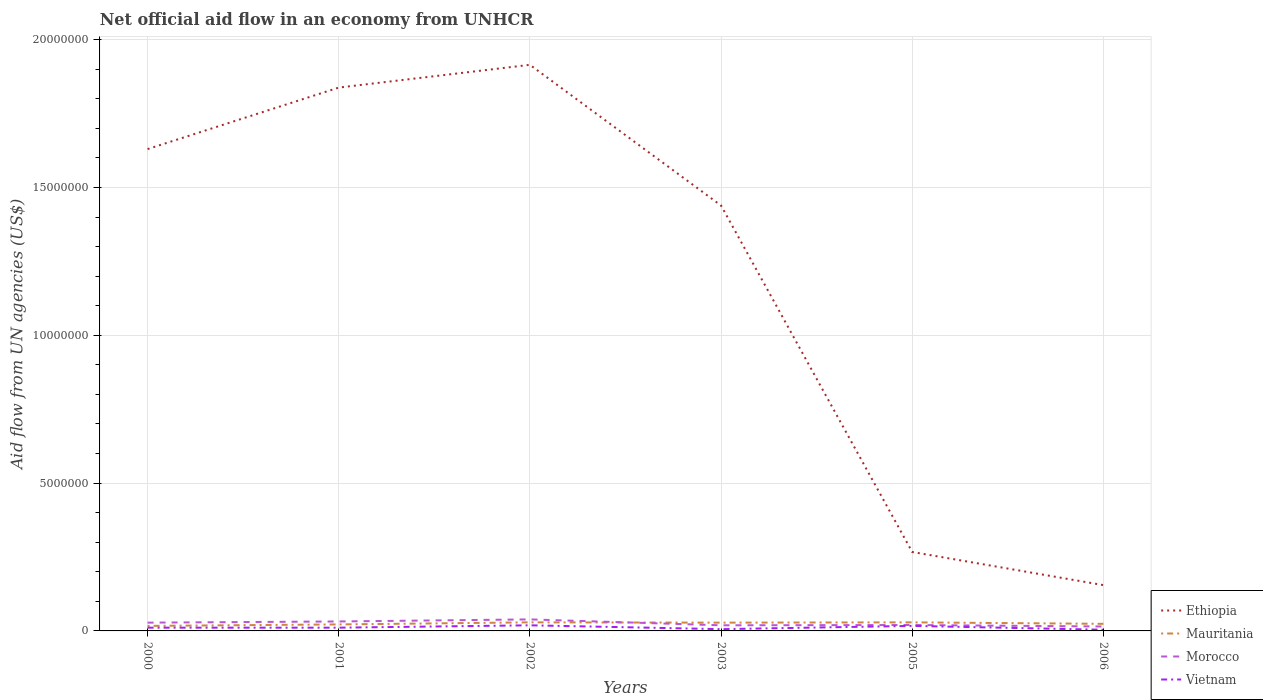How many different coloured lines are there?
Provide a succinct answer. 4. Does the line corresponding to Ethiopia intersect with the line corresponding to Vietnam?
Your answer should be very brief. No. What is the difference between the highest and the second highest net official aid flow in Vietnam?
Your answer should be compact. 1.50e+05. Is the net official aid flow in Mauritania strictly greater than the net official aid flow in Vietnam over the years?
Keep it short and to the point. No. How many lines are there?
Provide a short and direct response. 4. How many years are there in the graph?
Your response must be concise. 6. What is the difference between two consecutive major ticks on the Y-axis?
Offer a terse response. 5.00e+06. Does the graph contain any zero values?
Your answer should be compact. No. Does the graph contain grids?
Ensure brevity in your answer.  Yes. What is the title of the graph?
Provide a succinct answer. Net official aid flow in an economy from UNHCR. What is the label or title of the Y-axis?
Make the answer very short. Aid flow from UN agencies (US$). What is the Aid flow from UN agencies (US$) of Ethiopia in 2000?
Offer a very short reply. 1.63e+07. What is the Aid flow from UN agencies (US$) of Vietnam in 2000?
Offer a terse response. 1.10e+05. What is the Aid flow from UN agencies (US$) of Ethiopia in 2001?
Offer a terse response. 1.84e+07. What is the Aid flow from UN agencies (US$) in Vietnam in 2001?
Offer a very short reply. 1.10e+05. What is the Aid flow from UN agencies (US$) of Ethiopia in 2002?
Ensure brevity in your answer.  1.92e+07. What is the Aid flow from UN agencies (US$) in Mauritania in 2002?
Give a very brief answer. 2.90e+05. What is the Aid flow from UN agencies (US$) in Vietnam in 2002?
Your answer should be compact. 1.90e+05. What is the Aid flow from UN agencies (US$) in Ethiopia in 2003?
Give a very brief answer. 1.44e+07. What is the Aid flow from UN agencies (US$) of Ethiopia in 2005?
Keep it short and to the point. 2.67e+06. What is the Aid flow from UN agencies (US$) of Mauritania in 2005?
Offer a very short reply. 2.90e+05. What is the Aid flow from UN agencies (US$) in Morocco in 2005?
Give a very brief answer. 2.00e+05. What is the Aid flow from UN agencies (US$) in Ethiopia in 2006?
Your response must be concise. 1.55e+06. What is the Aid flow from UN agencies (US$) of Mauritania in 2006?
Your answer should be compact. 2.40e+05. What is the Aid flow from UN agencies (US$) in Morocco in 2006?
Ensure brevity in your answer.  1.50e+05. What is the Aid flow from UN agencies (US$) in Vietnam in 2006?
Your response must be concise. 4.00e+04. Across all years, what is the maximum Aid flow from UN agencies (US$) of Ethiopia?
Your response must be concise. 1.92e+07. Across all years, what is the maximum Aid flow from UN agencies (US$) of Morocco?
Offer a terse response. 3.90e+05. Across all years, what is the maximum Aid flow from UN agencies (US$) in Vietnam?
Keep it short and to the point. 1.90e+05. Across all years, what is the minimum Aid flow from UN agencies (US$) of Ethiopia?
Offer a very short reply. 1.55e+06. What is the total Aid flow from UN agencies (US$) of Ethiopia in the graph?
Your answer should be compact. 7.24e+07. What is the total Aid flow from UN agencies (US$) in Mauritania in the graph?
Your response must be concise. 1.49e+06. What is the total Aid flow from UN agencies (US$) in Morocco in the graph?
Offer a very short reply. 1.53e+06. What is the total Aid flow from UN agencies (US$) in Vietnam in the graph?
Offer a terse response. 6.80e+05. What is the difference between the Aid flow from UN agencies (US$) of Ethiopia in 2000 and that in 2001?
Your response must be concise. -2.08e+06. What is the difference between the Aid flow from UN agencies (US$) of Vietnam in 2000 and that in 2001?
Your answer should be very brief. 0. What is the difference between the Aid flow from UN agencies (US$) of Ethiopia in 2000 and that in 2002?
Your response must be concise. -2.85e+06. What is the difference between the Aid flow from UN agencies (US$) of Vietnam in 2000 and that in 2002?
Your response must be concise. -8.00e+04. What is the difference between the Aid flow from UN agencies (US$) in Ethiopia in 2000 and that in 2003?
Ensure brevity in your answer.  1.91e+06. What is the difference between the Aid flow from UN agencies (US$) in Ethiopia in 2000 and that in 2005?
Make the answer very short. 1.36e+07. What is the difference between the Aid flow from UN agencies (US$) in Morocco in 2000 and that in 2005?
Ensure brevity in your answer.  8.00e+04. What is the difference between the Aid flow from UN agencies (US$) in Ethiopia in 2000 and that in 2006?
Keep it short and to the point. 1.48e+07. What is the difference between the Aid flow from UN agencies (US$) in Mauritania in 2000 and that in 2006?
Make the answer very short. -7.00e+04. What is the difference between the Aid flow from UN agencies (US$) of Ethiopia in 2001 and that in 2002?
Keep it short and to the point. -7.70e+05. What is the difference between the Aid flow from UN agencies (US$) in Morocco in 2001 and that in 2002?
Provide a succinct answer. -7.00e+04. What is the difference between the Aid flow from UN agencies (US$) of Ethiopia in 2001 and that in 2003?
Make the answer very short. 3.99e+06. What is the difference between the Aid flow from UN agencies (US$) of Morocco in 2001 and that in 2003?
Ensure brevity in your answer.  1.30e+05. What is the difference between the Aid flow from UN agencies (US$) of Ethiopia in 2001 and that in 2005?
Make the answer very short. 1.57e+07. What is the difference between the Aid flow from UN agencies (US$) in Mauritania in 2001 and that in 2005?
Offer a terse response. -7.00e+04. What is the difference between the Aid flow from UN agencies (US$) of Morocco in 2001 and that in 2005?
Keep it short and to the point. 1.20e+05. What is the difference between the Aid flow from UN agencies (US$) of Vietnam in 2001 and that in 2005?
Give a very brief answer. -6.00e+04. What is the difference between the Aid flow from UN agencies (US$) of Ethiopia in 2001 and that in 2006?
Offer a very short reply. 1.68e+07. What is the difference between the Aid flow from UN agencies (US$) of Ethiopia in 2002 and that in 2003?
Your response must be concise. 4.76e+06. What is the difference between the Aid flow from UN agencies (US$) of Morocco in 2002 and that in 2003?
Offer a terse response. 2.00e+05. What is the difference between the Aid flow from UN agencies (US$) of Ethiopia in 2002 and that in 2005?
Ensure brevity in your answer.  1.65e+07. What is the difference between the Aid flow from UN agencies (US$) in Mauritania in 2002 and that in 2005?
Provide a short and direct response. 0. What is the difference between the Aid flow from UN agencies (US$) in Morocco in 2002 and that in 2005?
Keep it short and to the point. 1.90e+05. What is the difference between the Aid flow from UN agencies (US$) of Vietnam in 2002 and that in 2005?
Provide a short and direct response. 2.00e+04. What is the difference between the Aid flow from UN agencies (US$) of Ethiopia in 2002 and that in 2006?
Provide a short and direct response. 1.76e+07. What is the difference between the Aid flow from UN agencies (US$) in Mauritania in 2002 and that in 2006?
Your response must be concise. 5.00e+04. What is the difference between the Aid flow from UN agencies (US$) of Vietnam in 2002 and that in 2006?
Offer a terse response. 1.50e+05. What is the difference between the Aid flow from UN agencies (US$) of Ethiopia in 2003 and that in 2005?
Your answer should be compact. 1.17e+07. What is the difference between the Aid flow from UN agencies (US$) of Vietnam in 2003 and that in 2005?
Your answer should be compact. -1.10e+05. What is the difference between the Aid flow from UN agencies (US$) of Ethiopia in 2003 and that in 2006?
Provide a succinct answer. 1.28e+07. What is the difference between the Aid flow from UN agencies (US$) of Morocco in 2003 and that in 2006?
Keep it short and to the point. 4.00e+04. What is the difference between the Aid flow from UN agencies (US$) in Vietnam in 2003 and that in 2006?
Keep it short and to the point. 2.00e+04. What is the difference between the Aid flow from UN agencies (US$) in Ethiopia in 2005 and that in 2006?
Your answer should be compact. 1.12e+06. What is the difference between the Aid flow from UN agencies (US$) of Morocco in 2005 and that in 2006?
Your answer should be very brief. 5.00e+04. What is the difference between the Aid flow from UN agencies (US$) in Ethiopia in 2000 and the Aid flow from UN agencies (US$) in Mauritania in 2001?
Offer a terse response. 1.61e+07. What is the difference between the Aid flow from UN agencies (US$) in Ethiopia in 2000 and the Aid flow from UN agencies (US$) in Morocco in 2001?
Provide a succinct answer. 1.60e+07. What is the difference between the Aid flow from UN agencies (US$) of Ethiopia in 2000 and the Aid flow from UN agencies (US$) of Vietnam in 2001?
Make the answer very short. 1.62e+07. What is the difference between the Aid flow from UN agencies (US$) in Mauritania in 2000 and the Aid flow from UN agencies (US$) in Morocco in 2001?
Your answer should be very brief. -1.50e+05. What is the difference between the Aid flow from UN agencies (US$) in Morocco in 2000 and the Aid flow from UN agencies (US$) in Vietnam in 2001?
Ensure brevity in your answer.  1.70e+05. What is the difference between the Aid flow from UN agencies (US$) of Ethiopia in 2000 and the Aid flow from UN agencies (US$) of Mauritania in 2002?
Provide a short and direct response. 1.60e+07. What is the difference between the Aid flow from UN agencies (US$) of Ethiopia in 2000 and the Aid flow from UN agencies (US$) of Morocco in 2002?
Offer a very short reply. 1.59e+07. What is the difference between the Aid flow from UN agencies (US$) of Ethiopia in 2000 and the Aid flow from UN agencies (US$) of Vietnam in 2002?
Your answer should be compact. 1.61e+07. What is the difference between the Aid flow from UN agencies (US$) in Mauritania in 2000 and the Aid flow from UN agencies (US$) in Vietnam in 2002?
Offer a very short reply. -2.00e+04. What is the difference between the Aid flow from UN agencies (US$) of Ethiopia in 2000 and the Aid flow from UN agencies (US$) of Mauritania in 2003?
Your response must be concise. 1.60e+07. What is the difference between the Aid flow from UN agencies (US$) of Ethiopia in 2000 and the Aid flow from UN agencies (US$) of Morocco in 2003?
Provide a short and direct response. 1.61e+07. What is the difference between the Aid flow from UN agencies (US$) in Ethiopia in 2000 and the Aid flow from UN agencies (US$) in Vietnam in 2003?
Provide a succinct answer. 1.62e+07. What is the difference between the Aid flow from UN agencies (US$) of Mauritania in 2000 and the Aid flow from UN agencies (US$) of Morocco in 2003?
Your answer should be compact. -2.00e+04. What is the difference between the Aid flow from UN agencies (US$) in Ethiopia in 2000 and the Aid flow from UN agencies (US$) in Mauritania in 2005?
Provide a short and direct response. 1.60e+07. What is the difference between the Aid flow from UN agencies (US$) of Ethiopia in 2000 and the Aid flow from UN agencies (US$) of Morocco in 2005?
Provide a succinct answer. 1.61e+07. What is the difference between the Aid flow from UN agencies (US$) in Ethiopia in 2000 and the Aid flow from UN agencies (US$) in Vietnam in 2005?
Your response must be concise. 1.61e+07. What is the difference between the Aid flow from UN agencies (US$) of Mauritania in 2000 and the Aid flow from UN agencies (US$) of Vietnam in 2005?
Your answer should be compact. 0. What is the difference between the Aid flow from UN agencies (US$) of Ethiopia in 2000 and the Aid flow from UN agencies (US$) of Mauritania in 2006?
Provide a succinct answer. 1.61e+07. What is the difference between the Aid flow from UN agencies (US$) of Ethiopia in 2000 and the Aid flow from UN agencies (US$) of Morocco in 2006?
Offer a terse response. 1.62e+07. What is the difference between the Aid flow from UN agencies (US$) of Ethiopia in 2000 and the Aid flow from UN agencies (US$) of Vietnam in 2006?
Your response must be concise. 1.63e+07. What is the difference between the Aid flow from UN agencies (US$) of Mauritania in 2000 and the Aid flow from UN agencies (US$) of Vietnam in 2006?
Ensure brevity in your answer.  1.30e+05. What is the difference between the Aid flow from UN agencies (US$) of Morocco in 2000 and the Aid flow from UN agencies (US$) of Vietnam in 2006?
Offer a terse response. 2.40e+05. What is the difference between the Aid flow from UN agencies (US$) in Ethiopia in 2001 and the Aid flow from UN agencies (US$) in Mauritania in 2002?
Give a very brief answer. 1.81e+07. What is the difference between the Aid flow from UN agencies (US$) of Ethiopia in 2001 and the Aid flow from UN agencies (US$) of Morocco in 2002?
Provide a succinct answer. 1.80e+07. What is the difference between the Aid flow from UN agencies (US$) of Ethiopia in 2001 and the Aid flow from UN agencies (US$) of Vietnam in 2002?
Ensure brevity in your answer.  1.82e+07. What is the difference between the Aid flow from UN agencies (US$) of Ethiopia in 2001 and the Aid flow from UN agencies (US$) of Mauritania in 2003?
Keep it short and to the point. 1.81e+07. What is the difference between the Aid flow from UN agencies (US$) of Ethiopia in 2001 and the Aid flow from UN agencies (US$) of Morocco in 2003?
Make the answer very short. 1.82e+07. What is the difference between the Aid flow from UN agencies (US$) of Ethiopia in 2001 and the Aid flow from UN agencies (US$) of Vietnam in 2003?
Offer a terse response. 1.83e+07. What is the difference between the Aid flow from UN agencies (US$) in Mauritania in 2001 and the Aid flow from UN agencies (US$) in Morocco in 2003?
Offer a very short reply. 3.00e+04. What is the difference between the Aid flow from UN agencies (US$) in Morocco in 2001 and the Aid flow from UN agencies (US$) in Vietnam in 2003?
Offer a terse response. 2.60e+05. What is the difference between the Aid flow from UN agencies (US$) in Ethiopia in 2001 and the Aid flow from UN agencies (US$) in Mauritania in 2005?
Your answer should be compact. 1.81e+07. What is the difference between the Aid flow from UN agencies (US$) of Ethiopia in 2001 and the Aid flow from UN agencies (US$) of Morocco in 2005?
Make the answer very short. 1.82e+07. What is the difference between the Aid flow from UN agencies (US$) of Ethiopia in 2001 and the Aid flow from UN agencies (US$) of Vietnam in 2005?
Give a very brief answer. 1.82e+07. What is the difference between the Aid flow from UN agencies (US$) of Mauritania in 2001 and the Aid flow from UN agencies (US$) of Morocco in 2005?
Ensure brevity in your answer.  2.00e+04. What is the difference between the Aid flow from UN agencies (US$) in Mauritania in 2001 and the Aid flow from UN agencies (US$) in Vietnam in 2005?
Make the answer very short. 5.00e+04. What is the difference between the Aid flow from UN agencies (US$) of Morocco in 2001 and the Aid flow from UN agencies (US$) of Vietnam in 2005?
Keep it short and to the point. 1.50e+05. What is the difference between the Aid flow from UN agencies (US$) in Ethiopia in 2001 and the Aid flow from UN agencies (US$) in Mauritania in 2006?
Ensure brevity in your answer.  1.81e+07. What is the difference between the Aid flow from UN agencies (US$) of Ethiopia in 2001 and the Aid flow from UN agencies (US$) of Morocco in 2006?
Offer a very short reply. 1.82e+07. What is the difference between the Aid flow from UN agencies (US$) of Ethiopia in 2001 and the Aid flow from UN agencies (US$) of Vietnam in 2006?
Your response must be concise. 1.83e+07. What is the difference between the Aid flow from UN agencies (US$) of Mauritania in 2001 and the Aid flow from UN agencies (US$) of Morocco in 2006?
Keep it short and to the point. 7.00e+04. What is the difference between the Aid flow from UN agencies (US$) in Mauritania in 2001 and the Aid flow from UN agencies (US$) in Vietnam in 2006?
Offer a very short reply. 1.80e+05. What is the difference between the Aid flow from UN agencies (US$) of Morocco in 2001 and the Aid flow from UN agencies (US$) of Vietnam in 2006?
Provide a short and direct response. 2.80e+05. What is the difference between the Aid flow from UN agencies (US$) of Ethiopia in 2002 and the Aid flow from UN agencies (US$) of Mauritania in 2003?
Provide a short and direct response. 1.89e+07. What is the difference between the Aid flow from UN agencies (US$) of Ethiopia in 2002 and the Aid flow from UN agencies (US$) of Morocco in 2003?
Your response must be concise. 1.90e+07. What is the difference between the Aid flow from UN agencies (US$) in Ethiopia in 2002 and the Aid flow from UN agencies (US$) in Vietnam in 2003?
Your response must be concise. 1.91e+07. What is the difference between the Aid flow from UN agencies (US$) in Morocco in 2002 and the Aid flow from UN agencies (US$) in Vietnam in 2003?
Offer a terse response. 3.30e+05. What is the difference between the Aid flow from UN agencies (US$) of Ethiopia in 2002 and the Aid flow from UN agencies (US$) of Mauritania in 2005?
Your response must be concise. 1.89e+07. What is the difference between the Aid flow from UN agencies (US$) in Ethiopia in 2002 and the Aid flow from UN agencies (US$) in Morocco in 2005?
Provide a succinct answer. 1.90e+07. What is the difference between the Aid flow from UN agencies (US$) in Ethiopia in 2002 and the Aid flow from UN agencies (US$) in Vietnam in 2005?
Provide a succinct answer. 1.90e+07. What is the difference between the Aid flow from UN agencies (US$) of Mauritania in 2002 and the Aid flow from UN agencies (US$) of Morocco in 2005?
Offer a terse response. 9.00e+04. What is the difference between the Aid flow from UN agencies (US$) of Morocco in 2002 and the Aid flow from UN agencies (US$) of Vietnam in 2005?
Your answer should be compact. 2.20e+05. What is the difference between the Aid flow from UN agencies (US$) of Ethiopia in 2002 and the Aid flow from UN agencies (US$) of Mauritania in 2006?
Keep it short and to the point. 1.89e+07. What is the difference between the Aid flow from UN agencies (US$) in Ethiopia in 2002 and the Aid flow from UN agencies (US$) in Morocco in 2006?
Keep it short and to the point. 1.90e+07. What is the difference between the Aid flow from UN agencies (US$) in Ethiopia in 2002 and the Aid flow from UN agencies (US$) in Vietnam in 2006?
Ensure brevity in your answer.  1.91e+07. What is the difference between the Aid flow from UN agencies (US$) of Mauritania in 2002 and the Aid flow from UN agencies (US$) of Vietnam in 2006?
Your response must be concise. 2.50e+05. What is the difference between the Aid flow from UN agencies (US$) of Ethiopia in 2003 and the Aid flow from UN agencies (US$) of Mauritania in 2005?
Keep it short and to the point. 1.41e+07. What is the difference between the Aid flow from UN agencies (US$) of Ethiopia in 2003 and the Aid flow from UN agencies (US$) of Morocco in 2005?
Provide a succinct answer. 1.42e+07. What is the difference between the Aid flow from UN agencies (US$) in Ethiopia in 2003 and the Aid flow from UN agencies (US$) in Vietnam in 2005?
Your response must be concise. 1.42e+07. What is the difference between the Aid flow from UN agencies (US$) in Mauritania in 2003 and the Aid flow from UN agencies (US$) in Vietnam in 2005?
Provide a succinct answer. 1.10e+05. What is the difference between the Aid flow from UN agencies (US$) of Morocco in 2003 and the Aid flow from UN agencies (US$) of Vietnam in 2005?
Your answer should be very brief. 2.00e+04. What is the difference between the Aid flow from UN agencies (US$) in Ethiopia in 2003 and the Aid flow from UN agencies (US$) in Mauritania in 2006?
Provide a succinct answer. 1.42e+07. What is the difference between the Aid flow from UN agencies (US$) of Ethiopia in 2003 and the Aid flow from UN agencies (US$) of Morocco in 2006?
Offer a terse response. 1.42e+07. What is the difference between the Aid flow from UN agencies (US$) in Ethiopia in 2003 and the Aid flow from UN agencies (US$) in Vietnam in 2006?
Provide a succinct answer. 1.44e+07. What is the difference between the Aid flow from UN agencies (US$) of Ethiopia in 2005 and the Aid flow from UN agencies (US$) of Mauritania in 2006?
Provide a succinct answer. 2.43e+06. What is the difference between the Aid flow from UN agencies (US$) in Ethiopia in 2005 and the Aid flow from UN agencies (US$) in Morocco in 2006?
Provide a short and direct response. 2.52e+06. What is the difference between the Aid flow from UN agencies (US$) of Ethiopia in 2005 and the Aid flow from UN agencies (US$) of Vietnam in 2006?
Give a very brief answer. 2.63e+06. What is the average Aid flow from UN agencies (US$) in Ethiopia per year?
Your response must be concise. 1.21e+07. What is the average Aid flow from UN agencies (US$) of Mauritania per year?
Give a very brief answer. 2.48e+05. What is the average Aid flow from UN agencies (US$) of Morocco per year?
Offer a very short reply. 2.55e+05. What is the average Aid flow from UN agencies (US$) in Vietnam per year?
Provide a short and direct response. 1.13e+05. In the year 2000, what is the difference between the Aid flow from UN agencies (US$) in Ethiopia and Aid flow from UN agencies (US$) in Mauritania?
Your response must be concise. 1.61e+07. In the year 2000, what is the difference between the Aid flow from UN agencies (US$) in Ethiopia and Aid flow from UN agencies (US$) in Morocco?
Offer a terse response. 1.60e+07. In the year 2000, what is the difference between the Aid flow from UN agencies (US$) in Ethiopia and Aid flow from UN agencies (US$) in Vietnam?
Provide a short and direct response. 1.62e+07. In the year 2000, what is the difference between the Aid flow from UN agencies (US$) of Mauritania and Aid flow from UN agencies (US$) of Morocco?
Keep it short and to the point. -1.10e+05. In the year 2001, what is the difference between the Aid flow from UN agencies (US$) of Ethiopia and Aid flow from UN agencies (US$) of Mauritania?
Make the answer very short. 1.82e+07. In the year 2001, what is the difference between the Aid flow from UN agencies (US$) in Ethiopia and Aid flow from UN agencies (US$) in Morocco?
Keep it short and to the point. 1.81e+07. In the year 2001, what is the difference between the Aid flow from UN agencies (US$) in Ethiopia and Aid flow from UN agencies (US$) in Vietnam?
Provide a short and direct response. 1.83e+07. In the year 2001, what is the difference between the Aid flow from UN agencies (US$) of Mauritania and Aid flow from UN agencies (US$) of Morocco?
Provide a short and direct response. -1.00e+05. In the year 2001, what is the difference between the Aid flow from UN agencies (US$) of Morocco and Aid flow from UN agencies (US$) of Vietnam?
Ensure brevity in your answer.  2.10e+05. In the year 2002, what is the difference between the Aid flow from UN agencies (US$) of Ethiopia and Aid flow from UN agencies (US$) of Mauritania?
Your response must be concise. 1.89e+07. In the year 2002, what is the difference between the Aid flow from UN agencies (US$) in Ethiopia and Aid flow from UN agencies (US$) in Morocco?
Make the answer very short. 1.88e+07. In the year 2002, what is the difference between the Aid flow from UN agencies (US$) in Ethiopia and Aid flow from UN agencies (US$) in Vietnam?
Your answer should be very brief. 1.90e+07. In the year 2002, what is the difference between the Aid flow from UN agencies (US$) of Mauritania and Aid flow from UN agencies (US$) of Morocco?
Provide a short and direct response. -1.00e+05. In the year 2002, what is the difference between the Aid flow from UN agencies (US$) of Mauritania and Aid flow from UN agencies (US$) of Vietnam?
Provide a short and direct response. 1.00e+05. In the year 2002, what is the difference between the Aid flow from UN agencies (US$) of Morocco and Aid flow from UN agencies (US$) of Vietnam?
Make the answer very short. 2.00e+05. In the year 2003, what is the difference between the Aid flow from UN agencies (US$) in Ethiopia and Aid flow from UN agencies (US$) in Mauritania?
Your answer should be very brief. 1.41e+07. In the year 2003, what is the difference between the Aid flow from UN agencies (US$) in Ethiopia and Aid flow from UN agencies (US$) in Morocco?
Make the answer very short. 1.42e+07. In the year 2003, what is the difference between the Aid flow from UN agencies (US$) in Ethiopia and Aid flow from UN agencies (US$) in Vietnam?
Offer a very short reply. 1.43e+07. In the year 2003, what is the difference between the Aid flow from UN agencies (US$) in Mauritania and Aid flow from UN agencies (US$) in Morocco?
Make the answer very short. 9.00e+04. In the year 2003, what is the difference between the Aid flow from UN agencies (US$) of Morocco and Aid flow from UN agencies (US$) of Vietnam?
Make the answer very short. 1.30e+05. In the year 2005, what is the difference between the Aid flow from UN agencies (US$) in Ethiopia and Aid flow from UN agencies (US$) in Mauritania?
Make the answer very short. 2.38e+06. In the year 2005, what is the difference between the Aid flow from UN agencies (US$) of Ethiopia and Aid flow from UN agencies (US$) of Morocco?
Ensure brevity in your answer.  2.47e+06. In the year 2005, what is the difference between the Aid flow from UN agencies (US$) in Ethiopia and Aid flow from UN agencies (US$) in Vietnam?
Offer a very short reply. 2.50e+06. In the year 2005, what is the difference between the Aid flow from UN agencies (US$) of Mauritania and Aid flow from UN agencies (US$) of Vietnam?
Provide a succinct answer. 1.20e+05. In the year 2006, what is the difference between the Aid flow from UN agencies (US$) of Ethiopia and Aid flow from UN agencies (US$) of Mauritania?
Your response must be concise. 1.31e+06. In the year 2006, what is the difference between the Aid flow from UN agencies (US$) in Ethiopia and Aid flow from UN agencies (US$) in Morocco?
Ensure brevity in your answer.  1.40e+06. In the year 2006, what is the difference between the Aid flow from UN agencies (US$) of Ethiopia and Aid flow from UN agencies (US$) of Vietnam?
Offer a terse response. 1.51e+06. In the year 2006, what is the difference between the Aid flow from UN agencies (US$) of Mauritania and Aid flow from UN agencies (US$) of Morocco?
Your answer should be very brief. 9.00e+04. In the year 2006, what is the difference between the Aid flow from UN agencies (US$) of Mauritania and Aid flow from UN agencies (US$) of Vietnam?
Make the answer very short. 2.00e+05. In the year 2006, what is the difference between the Aid flow from UN agencies (US$) of Morocco and Aid flow from UN agencies (US$) of Vietnam?
Offer a very short reply. 1.10e+05. What is the ratio of the Aid flow from UN agencies (US$) in Ethiopia in 2000 to that in 2001?
Offer a very short reply. 0.89. What is the ratio of the Aid flow from UN agencies (US$) in Mauritania in 2000 to that in 2001?
Your answer should be compact. 0.77. What is the ratio of the Aid flow from UN agencies (US$) of Morocco in 2000 to that in 2001?
Keep it short and to the point. 0.88. What is the ratio of the Aid flow from UN agencies (US$) in Ethiopia in 2000 to that in 2002?
Your answer should be compact. 0.85. What is the ratio of the Aid flow from UN agencies (US$) in Mauritania in 2000 to that in 2002?
Keep it short and to the point. 0.59. What is the ratio of the Aid flow from UN agencies (US$) of Morocco in 2000 to that in 2002?
Provide a succinct answer. 0.72. What is the ratio of the Aid flow from UN agencies (US$) in Vietnam in 2000 to that in 2002?
Offer a terse response. 0.58. What is the ratio of the Aid flow from UN agencies (US$) in Ethiopia in 2000 to that in 2003?
Your response must be concise. 1.13. What is the ratio of the Aid flow from UN agencies (US$) in Mauritania in 2000 to that in 2003?
Ensure brevity in your answer.  0.61. What is the ratio of the Aid flow from UN agencies (US$) in Morocco in 2000 to that in 2003?
Offer a very short reply. 1.47. What is the ratio of the Aid flow from UN agencies (US$) of Vietnam in 2000 to that in 2003?
Offer a very short reply. 1.83. What is the ratio of the Aid flow from UN agencies (US$) of Ethiopia in 2000 to that in 2005?
Provide a short and direct response. 6.1. What is the ratio of the Aid flow from UN agencies (US$) of Mauritania in 2000 to that in 2005?
Make the answer very short. 0.59. What is the ratio of the Aid flow from UN agencies (US$) in Morocco in 2000 to that in 2005?
Your answer should be very brief. 1.4. What is the ratio of the Aid flow from UN agencies (US$) of Vietnam in 2000 to that in 2005?
Offer a very short reply. 0.65. What is the ratio of the Aid flow from UN agencies (US$) of Ethiopia in 2000 to that in 2006?
Ensure brevity in your answer.  10.52. What is the ratio of the Aid flow from UN agencies (US$) in Mauritania in 2000 to that in 2006?
Your response must be concise. 0.71. What is the ratio of the Aid flow from UN agencies (US$) in Morocco in 2000 to that in 2006?
Your answer should be very brief. 1.87. What is the ratio of the Aid flow from UN agencies (US$) of Vietnam in 2000 to that in 2006?
Your answer should be compact. 2.75. What is the ratio of the Aid flow from UN agencies (US$) in Ethiopia in 2001 to that in 2002?
Offer a very short reply. 0.96. What is the ratio of the Aid flow from UN agencies (US$) of Mauritania in 2001 to that in 2002?
Your answer should be very brief. 0.76. What is the ratio of the Aid flow from UN agencies (US$) of Morocco in 2001 to that in 2002?
Your answer should be very brief. 0.82. What is the ratio of the Aid flow from UN agencies (US$) of Vietnam in 2001 to that in 2002?
Give a very brief answer. 0.58. What is the ratio of the Aid flow from UN agencies (US$) in Ethiopia in 2001 to that in 2003?
Offer a very short reply. 1.28. What is the ratio of the Aid flow from UN agencies (US$) of Mauritania in 2001 to that in 2003?
Provide a succinct answer. 0.79. What is the ratio of the Aid flow from UN agencies (US$) of Morocco in 2001 to that in 2003?
Your answer should be compact. 1.68. What is the ratio of the Aid flow from UN agencies (US$) in Vietnam in 2001 to that in 2003?
Offer a terse response. 1.83. What is the ratio of the Aid flow from UN agencies (US$) in Ethiopia in 2001 to that in 2005?
Ensure brevity in your answer.  6.88. What is the ratio of the Aid flow from UN agencies (US$) in Mauritania in 2001 to that in 2005?
Provide a succinct answer. 0.76. What is the ratio of the Aid flow from UN agencies (US$) in Vietnam in 2001 to that in 2005?
Provide a succinct answer. 0.65. What is the ratio of the Aid flow from UN agencies (US$) of Ethiopia in 2001 to that in 2006?
Provide a short and direct response. 11.86. What is the ratio of the Aid flow from UN agencies (US$) of Mauritania in 2001 to that in 2006?
Provide a succinct answer. 0.92. What is the ratio of the Aid flow from UN agencies (US$) of Morocco in 2001 to that in 2006?
Make the answer very short. 2.13. What is the ratio of the Aid flow from UN agencies (US$) in Vietnam in 2001 to that in 2006?
Your answer should be very brief. 2.75. What is the ratio of the Aid flow from UN agencies (US$) in Ethiopia in 2002 to that in 2003?
Provide a succinct answer. 1.33. What is the ratio of the Aid flow from UN agencies (US$) in Mauritania in 2002 to that in 2003?
Make the answer very short. 1.04. What is the ratio of the Aid flow from UN agencies (US$) in Morocco in 2002 to that in 2003?
Keep it short and to the point. 2.05. What is the ratio of the Aid flow from UN agencies (US$) in Vietnam in 2002 to that in 2003?
Ensure brevity in your answer.  3.17. What is the ratio of the Aid flow from UN agencies (US$) in Ethiopia in 2002 to that in 2005?
Offer a terse response. 7.17. What is the ratio of the Aid flow from UN agencies (US$) in Mauritania in 2002 to that in 2005?
Your answer should be compact. 1. What is the ratio of the Aid flow from UN agencies (US$) of Morocco in 2002 to that in 2005?
Keep it short and to the point. 1.95. What is the ratio of the Aid flow from UN agencies (US$) of Vietnam in 2002 to that in 2005?
Ensure brevity in your answer.  1.12. What is the ratio of the Aid flow from UN agencies (US$) of Ethiopia in 2002 to that in 2006?
Your answer should be very brief. 12.35. What is the ratio of the Aid flow from UN agencies (US$) of Mauritania in 2002 to that in 2006?
Offer a terse response. 1.21. What is the ratio of the Aid flow from UN agencies (US$) of Vietnam in 2002 to that in 2006?
Your response must be concise. 4.75. What is the ratio of the Aid flow from UN agencies (US$) of Ethiopia in 2003 to that in 2005?
Offer a terse response. 5.39. What is the ratio of the Aid flow from UN agencies (US$) of Mauritania in 2003 to that in 2005?
Your answer should be compact. 0.97. What is the ratio of the Aid flow from UN agencies (US$) in Vietnam in 2003 to that in 2005?
Offer a very short reply. 0.35. What is the ratio of the Aid flow from UN agencies (US$) of Ethiopia in 2003 to that in 2006?
Give a very brief answer. 9.28. What is the ratio of the Aid flow from UN agencies (US$) of Mauritania in 2003 to that in 2006?
Provide a short and direct response. 1.17. What is the ratio of the Aid flow from UN agencies (US$) of Morocco in 2003 to that in 2006?
Give a very brief answer. 1.27. What is the ratio of the Aid flow from UN agencies (US$) of Ethiopia in 2005 to that in 2006?
Ensure brevity in your answer.  1.72. What is the ratio of the Aid flow from UN agencies (US$) in Mauritania in 2005 to that in 2006?
Keep it short and to the point. 1.21. What is the ratio of the Aid flow from UN agencies (US$) in Vietnam in 2005 to that in 2006?
Ensure brevity in your answer.  4.25. What is the difference between the highest and the second highest Aid flow from UN agencies (US$) of Ethiopia?
Your answer should be very brief. 7.70e+05. What is the difference between the highest and the lowest Aid flow from UN agencies (US$) of Ethiopia?
Keep it short and to the point. 1.76e+07. 